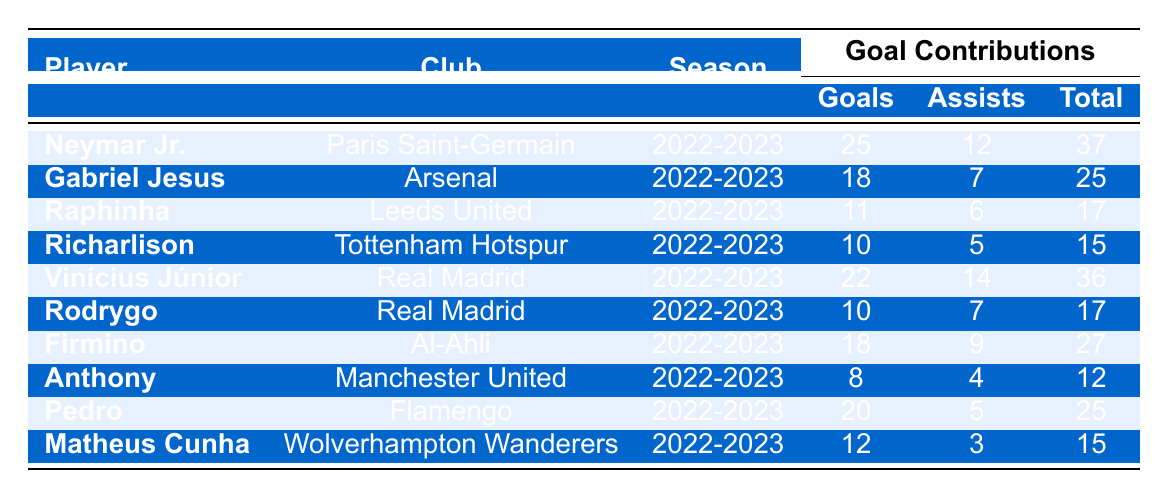What is the total number of goals scored by Neymar Jr. in the 2022-2023 season? According to the table, Neymar Jr. scored 25 goals in the 2022-2023 season.
Answer: 25 Which player had the highest total contributions among Brazilian forwards in the table? Neymar Jr. had the highest total contributions with 37, as indicated in the "Total" column.
Answer: Neymar Jr What is the total number of assists made by Vinícius Júnior in the 2022-2023 season? The table shows that Vinícius Júnior made 14 assists during the 2022-2023 season.
Answer: 14 Did any player score more than 20 goals in the 2022-2023 season? Yes, Neymar Jr. (25 goals) and Vinícius Júnior (22 goals) both scored more than 20 goals.
Answer: Yes What is the average number of goals scored by the players listed in the table? To find the average, sum all the goals (25 + 18 + 11 + 10 + 22 + 10 + 18 + 8 + 20 + 12 =  18.4) and divide by the number of players (10), so the average goals scored is 182/10 = 18.2.
Answer: 18.2 How many total contributions did Gabriel Jesus achieve? Gabriel Jesus's total contributions in the 2022-2023 season are listed as 25 in the "Total" column of the table.
Answer: 25 What is the difference in total contributions between Neymar Jr. and Anthony? Neymar Jr. had 37 total contributions while Anthony had 12; the difference is 37 – 12 = 25.
Answer: 25 Which club had two Brazilian forwards in the table? Real Madrid had two Brazilian forwards listed: Vinícius Júnior and Rodrygo.
Answer: Real Madrid What is the combined total contributions of the players from Real Madrid? The total contributions of Vinícius Júnior (36) and Rodrygo (17) sum up to 36 + 17 = 53.
Answer: 53 Did Raphinha contribute more with assists than Richarlison? Raphinha had 6 assists, while Richarlison had 5 assists, so Raphinha contributed more.
Answer: Yes What is the total number of goals scored by all players combined in the table? To get the total number of goals, sum all the goals scored: 25 + 18 + 11 + 10 + 22 + 10 + 18 + 8 + 20 + 12 =  154.
Answer: 154 